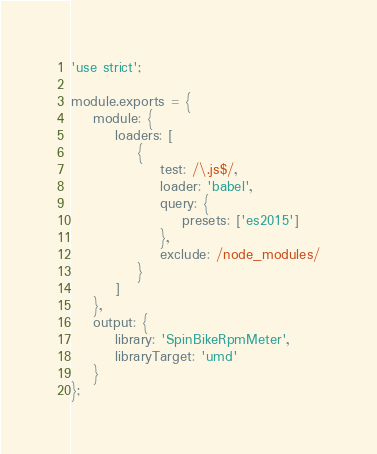<code> <loc_0><loc_0><loc_500><loc_500><_JavaScript_>'use strict';

module.exports = {
	module: {
		loaders: [
			{
				test: /\.js$/,
				loader: 'babel',
				query: {
					presets: ['es2015']
				},
				exclude: /node_modules/
			}
		]
	},
	output: {
		library: 'SpinBikeRpmMeter',
		libraryTarget: 'umd'
	}
};</code> 